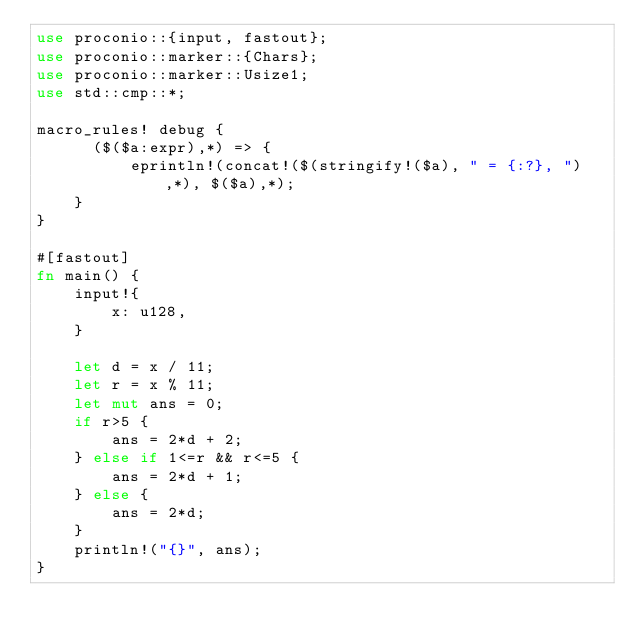<code> <loc_0><loc_0><loc_500><loc_500><_Rust_>use proconio::{input, fastout};
use proconio::marker::{Chars};
use proconio::marker::Usize1;
use std::cmp::*;

macro_rules! debug {
      ($($a:expr),*) => {
          eprintln!(concat!($(stringify!($a), " = {:?}, "),*), $($a),*);
    }
}

#[fastout]
fn main() {
    input!{
        x: u128,
    }

    let d = x / 11;
    let r = x % 11;
    let mut ans = 0;
    if r>5 {
        ans = 2*d + 2;
    } else if 1<=r && r<=5 {
        ans = 2*d + 1;
    } else {
        ans = 2*d;
    }
    println!("{}", ans);
}
</code> 